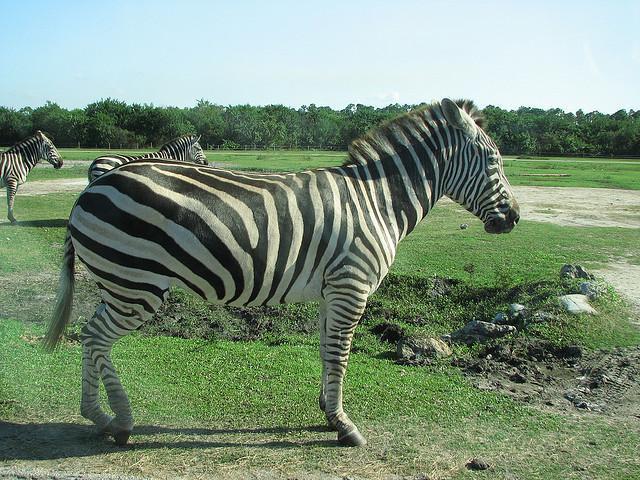How many zebras are in the photo?
Give a very brief answer. 3. 